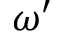<formula> <loc_0><loc_0><loc_500><loc_500>\omega ^ { \prime }</formula> 